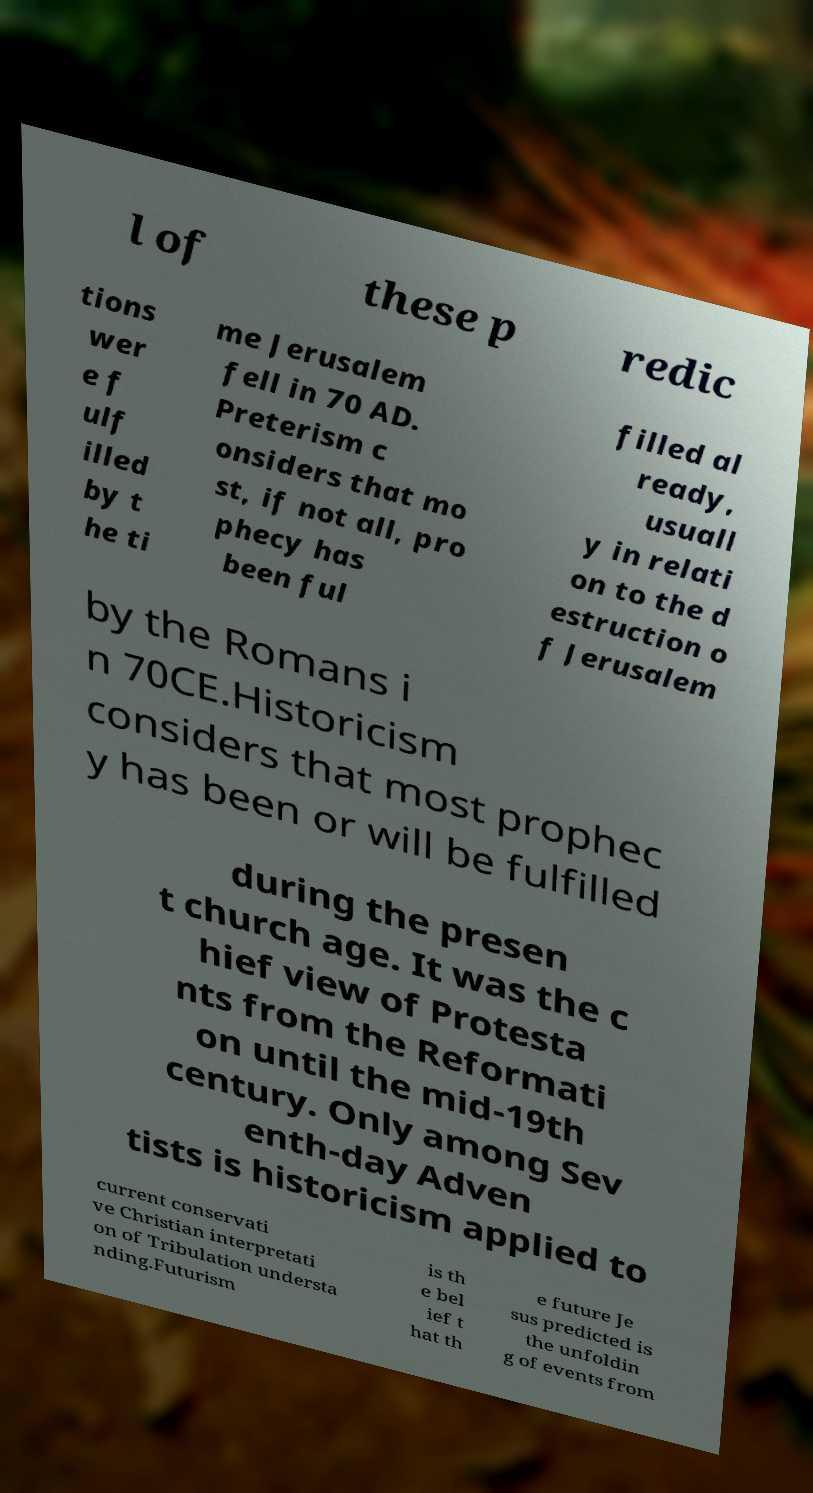Please identify and transcribe the text found in this image. l of these p redic tions wer e f ulf illed by t he ti me Jerusalem fell in 70 AD. Preterism c onsiders that mo st, if not all, pro phecy has been ful filled al ready, usuall y in relati on to the d estruction o f Jerusalem by the Romans i n 70CE.Historicism considers that most prophec y has been or will be fulfilled during the presen t church age. It was the c hief view of Protesta nts from the Reformati on until the mid-19th century. Only among Sev enth-day Adven tists is historicism applied to current conservati ve Christian interpretati on of Tribulation understa nding.Futurism is th e bel ief t hat th e future Je sus predicted is the unfoldin g of events from 